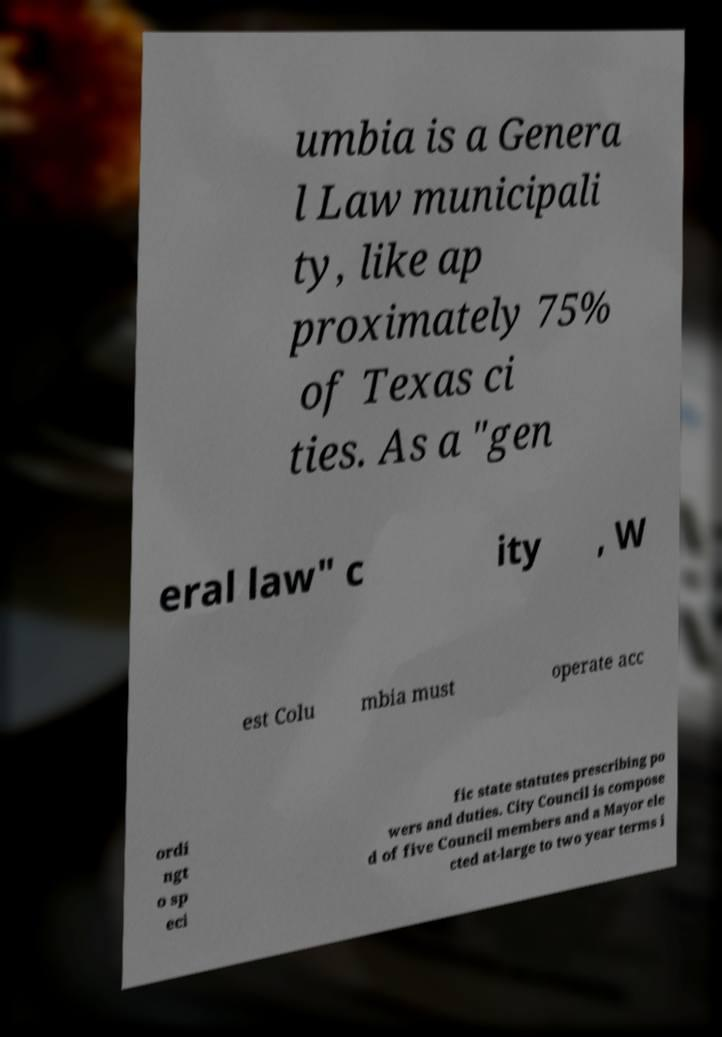Could you assist in decoding the text presented in this image and type it out clearly? umbia is a Genera l Law municipali ty, like ap proximately 75% of Texas ci ties. As a "gen eral law" c ity , W est Colu mbia must operate acc ordi ngt o sp eci fic state statutes prescribing po wers and duties. City Council is compose d of five Council members and a Mayor ele cted at-large to two year terms i 